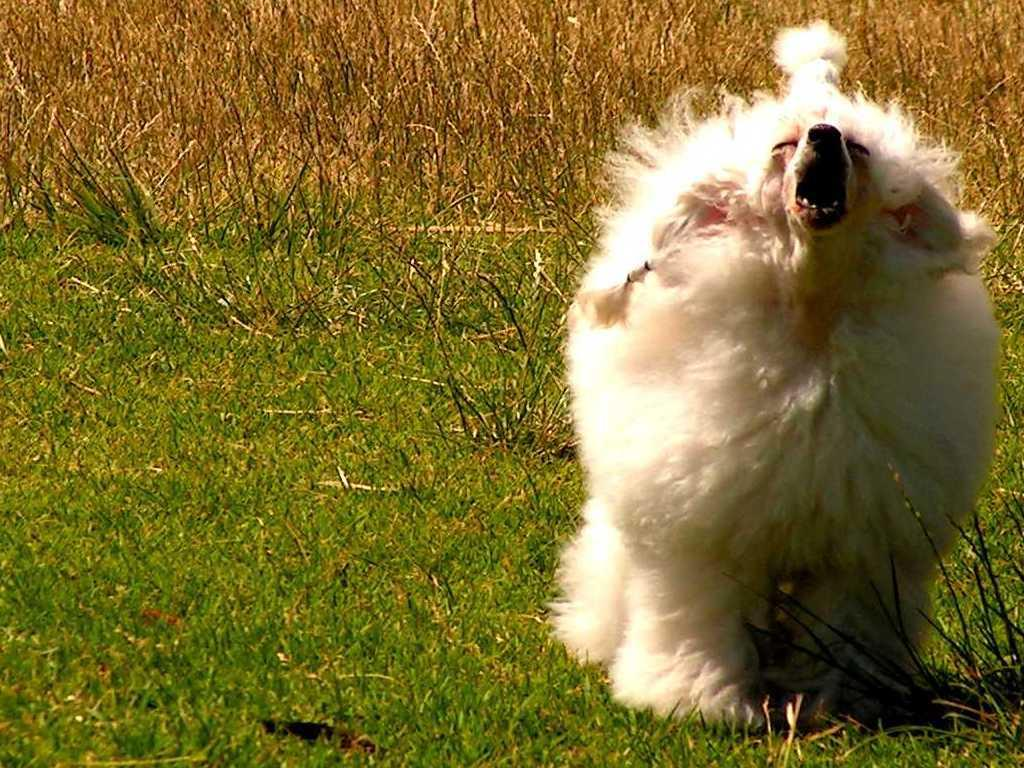What type of creature can be seen in the image? There is an animal in the image. Where is the animal located in the image? The animal is on the right side of the image. What color is the animal in the image? The animal is white in color. What type of vegetation is visible on the ground in the image? There is grass visible on the ground in the image. What type of juice can be seen in the animal's sack in the image? There is no juice or sack present in the image; it features a white animal on the right side of the image with grass visible on the ground. 